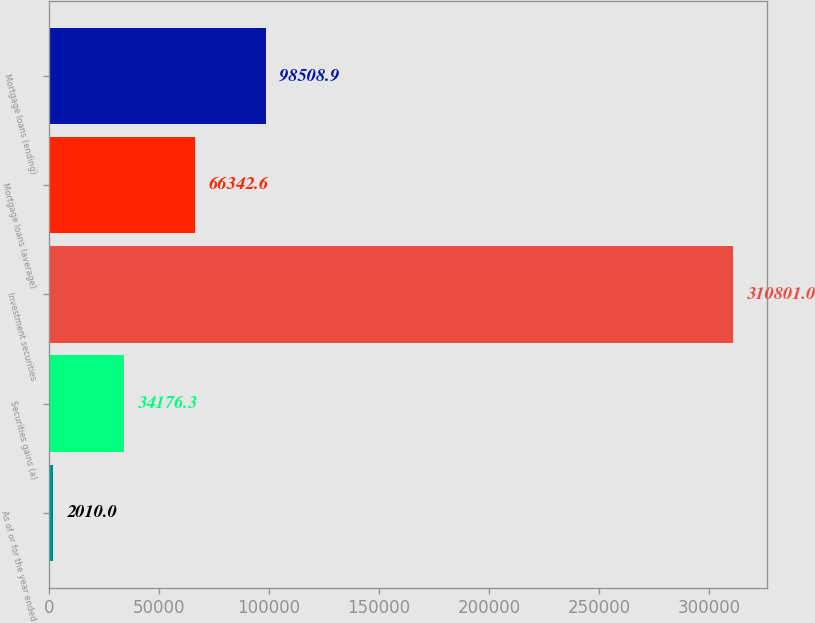Convert chart. <chart><loc_0><loc_0><loc_500><loc_500><bar_chart><fcel>As of or for the year ended<fcel>Securities gains (a)<fcel>Investment securities<fcel>Mortgage loans (average)<fcel>Mortgage loans (ending)<nl><fcel>2010<fcel>34176.3<fcel>310801<fcel>66342.6<fcel>98508.9<nl></chart> 